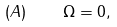Convert formula to latex. <formula><loc_0><loc_0><loc_500><loc_500>( A ) \quad \Omega = 0 ,</formula> 